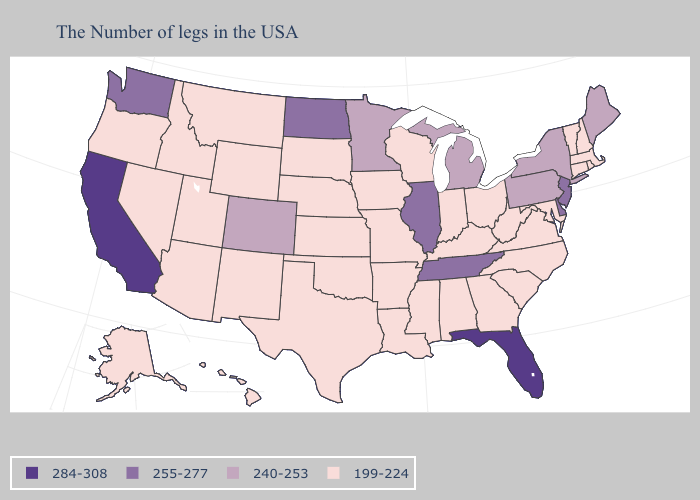Does Kansas have the highest value in the USA?
Short answer required. No. Is the legend a continuous bar?
Answer briefly. No. What is the value of California?
Short answer required. 284-308. Name the states that have a value in the range 255-277?
Be succinct. New Jersey, Delaware, Tennessee, Illinois, North Dakota, Washington. Among the states that border Ohio , which have the lowest value?
Be succinct. West Virginia, Kentucky, Indiana. Which states hav the highest value in the Northeast?
Be succinct. New Jersey. What is the value of Arkansas?
Give a very brief answer. 199-224. What is the highest value in the USA?
Keep it brief. 284-308. Which states have the lowest value in the USA?
Quick response, please. Massachusetts, Rhode Island, New Hampshire, Vermont, Connecticut, Maryland, Virginia, North Carolina, South Carolina, West Virginia, Ohio, Georgia, Kentucky, Indiana, Alabama, Wisconsin, Mississippi, Louisiana, Missouri, Arkansas, Iowa, Kansas, Nebraska, Oklahoma, Texas, South Dakota, Wyoming, New Mexico, Utah, Montana, Arizona, Idaho, Nevada, Oregon, Alaska, Hawaii. Among the states that border Ohio , does Pennsylvania have the lowest value?
Write a very short answer. No. Name the states that have a value in the range 240-253?
Quick response, please. Maine, New York, Pennsylvania, Michigan, Minnesota, Colorado. Does New Jersey have a lower value than California?
Concise answer only. Yes. Which states have the highest value in the USA?
Concise answer only. Florida, California. 